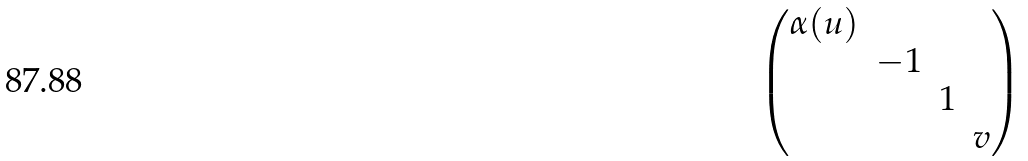Convert formula to latex. <formula><loc_0><loc_0><loc_500><loc_500>\begin{pmatrix} \alpha ( u ) \\ & - 1 \\ & & 1 \\ & & & v \end{pmatrix}</formula> 